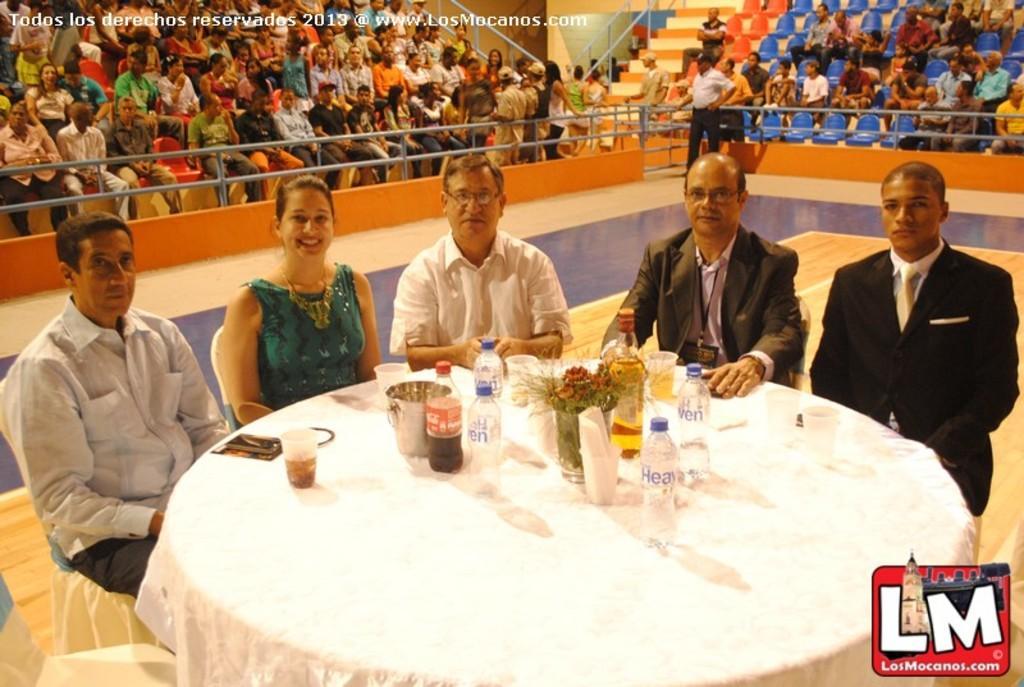In one or two sentences, can you explain what this image depicts? In the background we can see people sitting on the chairs. We can see the stairs and a railing. A man is standing. We can see four men and a woman sitting on the chairs near to a table. On the table we can see bottles, glasses, tissue in a glass, flower vase and few objects. At the bottom we can see the floor. At the top we can see there is something written. In the bottom right corner there is a logo. 